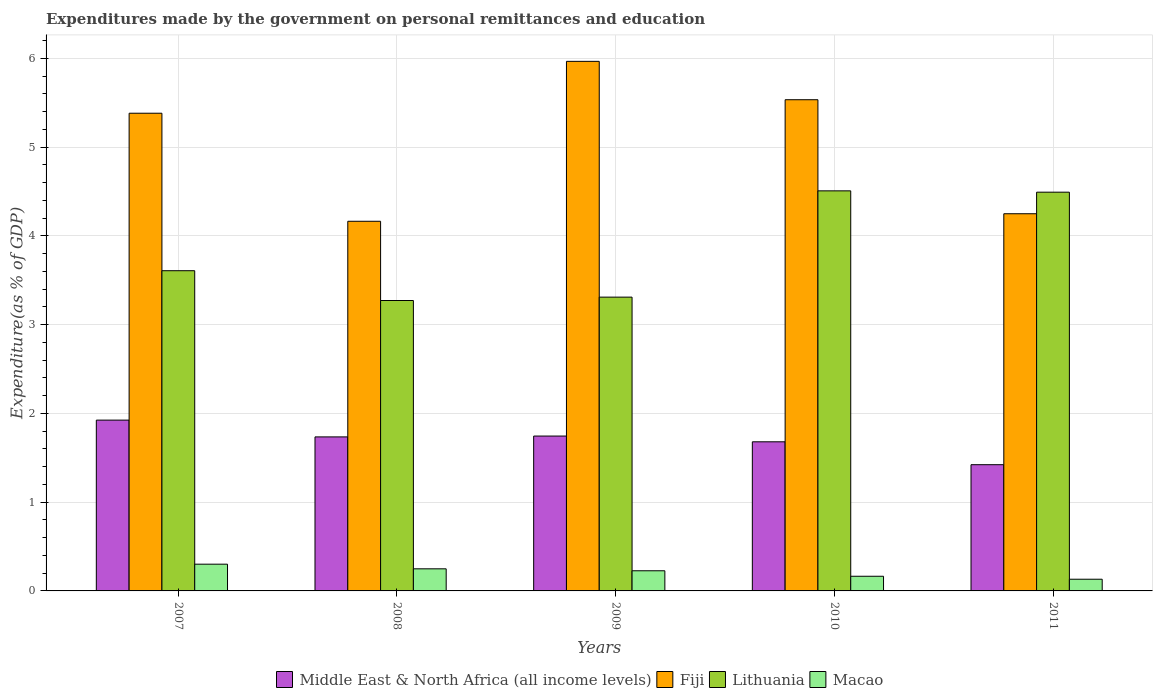How many different coloured bars are there?
Keep it short and to the point. 4. Are the number of bars per tick equal to the number of legend labels?
Provide a succinct answer. Yes. How many bars are there on the 5th tick from the left?
Make the answer very short. 4. In how many cases, is the number of bars for a given year not equal to the number of legend labels?
Offer a very short reply. 0. What is the expenditures made by the government on personal remittances and education in Fiji in 2008?
Your answer should be very brief. 4.16. Across all years, what is the maximum expenditures made by the government on personal remittances and education in Macao?
Your answer should be very brief. 0.3. Across all years, what is the minimum expenditures made by the government on personal remittances and education in Fiji?
Make the answer very short. 4.16. In which year was the expenditures made by the government on personal remittances and education in Middle East & North Africa (all income levels) minimum?
Your response must be concise. 2011. What is the total expenditures made by the government on personal remittances and education in Lithuania in the graph?
Provide a succinct answer. 19.19. What is the difference between the expenditures made by the government on personal remittances and education in Lithuania in 2008 and that in 2011?
Offer a very short reply. -1.22. What is the difference between the expenditures made by the government on personal remittances and education in Lithuania in 2008 and the expenditures made by the government on personal remittances and education in Macao in 2010?
Keep it short and to the point. 3.11. What is the average expenditures made by the government on personal remittances and education in Macao per year?
Ensure brevity in your answer.  0.21. In the year 2011, what is the difference between the expenditures made by the government on personal remittances and education in Fiji and expenditures made by the government on personal remittances and education in Middle East & North Africa (all income levels)?
Offer a terse response. 2.83. In how many years, is the expenditures made by the government on personal remittances and education in Macao greater than 4.6 %?
Offer a very short reply. 0. What is the ratio of the expenditures made by the government on personal remittances and education in Lithuania in 2007 to that in 2009?
Keep it short and to the point. 1.09. What is the difference between the highest and the second highest expenditures made by the government on personal remittances and education in Lithuania?
Offer a very short reply. 0.01. What is the difference between the highest and the lowest expenditures made by the government on personal remittances and education in Macao?
Your answer should be compact. 0.17. In how many years, is the expenditures made by the government on personal remittances and education in Fiji greater than the average expenditures made by the government on personal remittances and education in Fiji taken over all years?
Your response must be concise. 3. Is the sum of the expenditures made by the government on personal remittances and education in Lithuania in 2009 and 2010 greater than the maximum expenditures made by the government on personal remittances and education in Macao across all years?
Provide a short and direct response. Yes. Is it the case that in every year, the sum of the expenditures made by the government on personal remittances and education in Middle East & North Africa (all income levels) and expenditures made by the government on personal remittances and education in Macao is greater than the sum of expenditures made by the government on personal remittances and education in Lithuania and expenditures made by the government on personal remittances and education in Fiji?
Your answer should be very brief. No. What does the 2nd bar from the left in 2009 represents?
Provide a succinct answer. Fiji. What does the 3rd bar from the right in 2011 represents?
Keep it short and to the point. Fiji. Are all the bars in the graph horizontal?
Keep it short and to the point. No. How many years are there in the graph?
Offer a terse response. 5. Are the values on the major ticks of Y-axis written in scientific E-notation?
Keep it short and to the point. No. Does the graph contain any zero values?
Ensure brevity in your answer.  No. How many legend labels are there?
Give a very brief answer. 4. How are the legend labels stacked?
Offer a very short reply. Horizontal. What is the title of the graph?
Your response must be concise. Expenditures made by the government on personal remittances and education. What is the label or title of the X-axis?
Your response must be concise. Years. What is the label or title of the Y-axis?
Give a very brief answer. Expenditure(as % of GDP). What is the Expenditure(as % of GDP) of Middle East & North Africa (all income levels) in 2007?
Offer a terse response. 1.92. What is the Expenditure(as % of GDP) in Fiji in 2007?
Give a very brief answer. 5.38. What is the Expenditure(as % of GDP) of Lithuania in 2007?
Provide a short and direct response. 3.61. What is the Expenditure(as % of GDP) in Macao in 2007?
Give a very brief answer. 0.3. What is the Expenditure(as % of GDP) in Middle East & North Africa (all income levels) in 2008?
Provide a succinct answer. 1.73. What is the Expenditure(as % of GDP) in Fiji in 2008?
Offer a terse response. 4.16. What is the Expenditure(as % of GDP) of Lithuania in 2008?
Keep it short and to the point. 3.27. What is the Expenditure(as % of GDP) in Macao in 2008?
Your answer should be compact. 0.25. What is the Expenditure(as % of GDP) of Middle East & North Africa (all income levels) in 2009?
Provide a short and direct response. 1.74. What is the Expenditure(as % of GDP) in Fiji in 2009?
Ensure brevity in your answer.  5.97. What is the Expenditure(as % of GDP) of Lithuania in 2009?
Ensure brevity in your answer.  3.31. What is the Expenditure(as % of GDP) in Macao in 2009?
Provide a short and direct response. 0.23. What is the Expenditure(as % of GDP) of Middle East & North Africa (all income levels) in 2010?
Your answer should be very brief. 1.68. What is the Expenditure(as % of GDP) of Fiji in 2010?
Provide a short and direct response. 5.53. What is the Expenditure(as % of GDP) in Lithuania in 2010?
Give a very brief answer. 4.51. What is the Expenditure(as % of GDP) in Macao in 2010?
Give a very brief answer. 0.17. What is the Expenditure(as % of GDP) of Middle East & North Africa (all income levels) in 2011?
Provide a short and direct response. 1.42. What is the Expenditure(as % of GDP) of Fiji in 2011?
Ensure brevity in your answer.  4.25. What is the Expenditure(as % of GDP) of Lithuania in 2011?
Provide a short and direct response. 4.49. What is the Expenditure(as % of GDP) in Macao in 2011?
Provide a succinct answer. 0.13. Across all years, what is the maximum Expenditure(as % of GDP) of Middle East & North Africa (all income levels)?
Provide a short and direct response. 1.92. Across all years, what is the maximum Expenditure(as % of GDP) of Fiji?
Keep it short and to the point. 5.97. Across all years, what is the maximum Expenditure(as % of GDP) in Lithuania?
Keep it short and to the point. 4.51. Across all years, what is the maximum Expenditure(as % of GDP) of Macao?
Offer a terse response. 0.3. Across all years, what is the minimum Expenditure(as % of GDP) of Middle East & North Africa (all income levels)?
Keep it short and to the point. 1.42. Across all years, what is the minimum Expenditure(as % of GDP) in Fiji?
Give a very brief answer. 4.16. Across all years, what is the minimum Expenditure(as % of GDP) in Lithuania?
Your answer should be very brief. 3.27. Across all years, what is the minimum Expenditure(as % of GDP) of Macao?
Your answer should be very brief. 0.13. What is the total Expenditure(as % of GDP) in Middle East & North Africa (all income levels) in the graph?
Ensure brevity in your answer.  8.51. What is the total Expenditure(as % of GDP) of Fiji in the graph?
Provide a succinct answer. 25.29. What is the total Expenditure(as % of GDP) in Lithuania in the graph?
Make the answer very short. 19.19. What is the total Expenditure(as % of GDP) in Macao in the graph?
Your answer should be very brief. 1.07. What is the difference between the Expenditure(as % of GDP) of Middle East & North Africa (all income levels) in 2007 and that in 2008?
Keep it short and to the point. 0.19. What is the difference between the Expenditure(as % of GDP) of Fiji in 2007 and that in 2008?
Provide a short and direct response. 1.22. What is the difference between the Expenditure(as % of GDP) in Lithuania in 2007 and that in 2008?
Your answer should be very brief. 0.34. What is the difference between the Expenditure(as % of GDP) of Macao in 2007 and that in 2008?
Offer a very short reply. 0.05. What is the difference between the Expenditure(as % of GDP) of Middle East & North Africa (all income levels) in 2007 and that in 2009?
Your answer should be very brief. 0.18. What is the difference between the Expenditure(as % of GDP) in Fiji in 2007 and that in 2009?
Offer a terse response. -0.58. What is the difference between the Expenditure(as % of GDP) of Lithuania in 2007 and that in 2009?
Keep it short and to the point. 0.3. What is the difference between the Expenditure(as % of GDP) in Macao in 2007 and that in 2009?
Your response must be concise. 0.07. What is the difference between the Expenditure(as % of GDP) of Middle East & North Africa (all income levels) in 2007 and that in 2010?
Give a very brief answer. 0.24. What is the difference between the Expenditure(as % of GDP) of Fiji in 2007 and that in 2010?
Keep it short and to the point. -0.15. What is the difference between the Expenditure(as % of GDP) in Lithuania in 2007 and that in 2010?
Keep it short and to the point. -0.9. What is the difference between the Expenditure(as % of GDP) of Macao in 2007 and that in 2010?
Offer a very short reply. 0.14. What is the difference between the Expenditure(as % of GDP) of Middle East & North Africa (all income levels) in 2007 and that in 2011?
Provide a succinct answer. 0.5. What is the difference between the Expenditure(as % of GDP) in Fiji in 2007 and that in 2011?
Your response must be concise. 1.13. What is the difference between the Expenditure(as % of GDP) in Lithuania in 2007 and that in 2011?
Your answer should be compact. -0.88. What is the difference between the Expenditure(as % of GDP) of Macao in 2007 and that in 2011?
Your answer should be compact. 0.17. What is the difference between the Expenditure(as % of GDP) of Middle East & North Africa (all income levels) in 2008 and that in 2009?
Ensure brevity in your answer.  -0.01. What is the difference between the Expenditure(as % of GDP) of Fiji in 2008 and that in 2009?
Provide a short and direct response. -1.8. What is the difference between the Expenditure(as % of GDP) in Lithuania in 2008 and that in 2009?
Keep it short and to the point. -0.04. What is the difference between the Expenditure(as % of GDP) in Macao in 2008 and that in 2009?
Give a very brief answer. 0.02. What is the difference between the Expenditure(as % of GDP) in Middle East & North Africa (all income levels) in 2008 and that in 2010?
Your answer should be very brief. 0.06. What is the difference between the Expenditure(as % of GDP) of Fiji in 2008 and that in 2010?
Ensure brevity in your answer.  -1.37. What is the difference between the Expenditure(as % of GDP) of Lithuania in 2008 and that in 2010?
Ensure brevity in your answer.  -1.24. What is the difference between the Expenditure(as % of GDP) of Macao in 2008 and that in 2010?
Provide a short and direct response. 0.08. What is the difference between the Expenditure(as % of GDP) of Middle East & North Africa (all income levels) in 2008 and that in 2011?
Provide a succinct answer. 0.31. What is the difference between the Expenditure(as % of GDP) of Fiji in 2008 and that in 2011?
Keep it short and to the point. -0.08. What is the difference between the Expenditure(as % of GDP) in Lithuania in 2008 and that in 2011?
Offer a very short reply. -1.22. What is the difference between the Expenditure(as % of GDP) in Macao in 2008 and that in 2011?
Keep it short and to the point. 0.12. What is the difference between the Expenditure(as % of GDP) of Middle East & North Africa (all income levels) in 2009 and that in 2010?
Offer a very short reply. 0.06. What is the difference between the Expenditure(as % of GDP) of Fiji in 2009 and that in 2010?
Your response must be concise. 0.43. What is the difference between the Expenditure(as % of GDP) of Lithuania in 2009 and that in 2010?
Make the answer very short. -1.2. What is the difference between the Expenditure(as % of GDP) of Macao in 2009 and that in 2010?
Provide a succinct answer. 0.06. What is the difference between the Expenditure(as % of GDP) of Middle East & North Africa (all income levels) in 2009 and that in 2011?
Keep it short and to the point. 0.32. What is the difference between the Expenditure(as % of GDP) in Fiji in 2009 and that in 2011?
Offer a very short reply. 1.72. What is the difference between the Expenditure(as % of GDP) of Lithuania in 2009 and that in 2011?
Ensure brevity in your answer.  -1.18. What is the difference between the Expenditure(as % of GDP) in Macao in 2009 and that in 2011?
Your answer should be very brief. 0.1. What is the difference between the Expenditure(as % of GDP) in Middle East & North Africa (all income levels) in 2010 and that in 2011?
Offer a terse response. 0.26. What is the difference between the Expenditure(as % of GDP) of Fiji in 2010 and that in 2011?
Offer a very short reply. 1.28. What is the difference between the Expenditure(as % of GDP) of Lithuania in 2010 and that in 2011?
Provide a succinct answer. 0.01. What is the difference between the Expenditure(as % of GDP) in Macao in 2010 and that in 2011?
Your answer should be compact. 0.03. What is the difference between the Expenditure(as % of GDP) in Middle East & North Africa (all income levels) in 2007 and the Expenditure(as % of GDP) in Fiji in 2008?
Ensure brevity in your answer.  -2.24. What is the difference between the Expenditure(as % of GDP) in Middle East & North Africa (all income levels) in 2007 and the Expenditure(as % of GDP) in Lithuania in 2008?
Offer a terse response. -1.35. What is the difference between the Expenditure(as % of GDP) in Middle East & North Africa (all income levels) in 2007 and the Expenditure(as % of GDP) in Macao in 2008?
Ensure brevity in your answer.  1.68. What is the difference between the Expenditure(as % of GDP) of Fiji in 2007 and the Expenditure(as % of GDP) of Lithuania in 2008?
Offer a terse response. 2.11. What is the difference between the Expenditure(as % of GDP) of Fiji in 2007 and the Expenditure(as % of GDP) of Macao in 2008?
Offer a very short reply. 5.13. What is the difference between the Expenditure(as % of GDP) of Lithuania in 2007 and the Expenditure(as % of GDP) of Macao in 2008?
Your answer should be compact. 3.36. What is the difference between the Expenditure(as % of GDP) in Middle East & North Africa (all income levels) in 2007 and the Expenditure(as % of GDP) in Fiji in 2009?
Give a very brief answer. -4.04. What is the difference between the Expenditure(as % of GDP) in Middle East & North Africa (all income levels) in 2007 and the Expenditure(as % of GDP) in Lithuania in 2009?
Give a very brief answer. -1.39. What is the difference between the Expenditure(as % of GDP) in Middle East & North Africa (all income levels) in 2007 and the Expenditure(as % of GDP) in Macao in 2009?
Offer a very short reply. 1.7. What is the difference between the Expenditure(as % of GDP) in Fiji in 2007 and the Expenditure(as % of GDP) in Lithuania in 2009?
Your response must be concise. 2.07. What is the difference between the Expenditure(as % of GDP) in Fiji in 2007 and the Expenditure(as % of GDP) in Macao in 2009?
Keep it short and to the point. 5.15. What is the difference between the Expenditure(as % of GDP) of Lithuania in 2007 and the Expenditure(as % of GDP) of Macao in 2009?
Your answer should be compact. 3.38. What is the difference between the Expenditure(as % of GDP) in Middle East & North Africa (all income levels) in 2007 and the Expenditure(as % of GDP) in Fiji in 2010?
Your response must be concise. -3.61. What is the difference between the Expenditure(as % of GDP) in Middle East & North Africa (all income levels) in 2007 and the Expenditure(as % of GDP) in Lithuania in 2010?
Keep it short and to the point. -2.58. What is the difference between the Expenditure(as % of GDP) of Middle East & North Africa (all income levels) in 2007 and the Expenditure(as % of GDP) of Macao in 2010?
Your answer should be compact. 1.76. What is the difference between the Expenditure(as % of GDP) of Fiji in 2007 and the Expenditure(as % of GDP) of Lithuania in 2010?
Make the answer very short. 0.87. What is the difference between the Expenditure(as % of GDP) in Fiji in 2007 and the Expenditure(as % of GDP) in Macao in 2010?
Keep it short and to the point. 5.22. What is the difference between the Expenditure(as % of GDP) of Lithuania in 2007 and the Expenditure(as % of GDP) of Macao in 2010?
Your response must be concise. 3.44. What is the difference between the Expenditure(as % of GDP) in Middle East & North Africa (all income levels) in 2007 and the Expenditure(as % of GDP) in Fiji in 2011?
Your answer should be compact. -2.32. What is the difference between the Expenditure(as % of GDP) of Middle East & North Africa (all income levels) in 2007 and the Expenditure(as % of GDP) of Lithuania in 2011?
Make the answer very short. -2.57. What is the difference between the Expenditure(as % of GDP) in Middle East & North Africa (all income levels) in 2007 and the Expenditure(as % of GDP) in Macao in 2011?
Ensure brevity in your answer.  1.79. What is the difference between the Expenditure(as % of GDP) of Fiji in 2007 and the Expenditure(as % of GDP) of Lithuania in 2011?
Make the answer very short. 0.89. What is the difference between the Expenditure(as % of GDP) of Fiji in 2007 and the Expenditure(as % of GDP) of Macao in 2011?
Your response must be concise. 5.25. What is the difference between the Expenditure(as % of GDP) in Lithuania in 2007 and the Expenditure(as % of GDP) in Macao in 2011?
Give a very brief answer. 3.48. What is the difference between the Expenditure(as % of GDP) of Middle East & North Africa (all income levels) in 2008 and the Expenditure(as % of GDP) of Fiji in 2009?
Provide a short and direct response. -4.23. What is the difference between the Expenditure(as % of GDP) in Middle East & North Africa (all income levels) in 2008 and the Expenditure(as % of GDP) in Lithuania in 2009?
Ensure brevity in your answer.  -1.57. What is the difference between the Expenditure(as % of GDP) of Middle East & North Africa (all income levels) in 2008 and the Expenditure(as % of GDP) of Macao in 2009?
Make the answer very short. 1.51. What is the difference between the Expenditure(as % of GDP) of Fiji in 2008 and the Expenditure(as % of GDP) of Lithuania in 2009?
Give a very brief answer. 0.85. What is the difference between the Expenditure(as % of GDP) in Fiji in 2008 and the Expenditure(as % of GDP) in Macao in 2009?
Keep it short and to the point. 3.94. What is the difference between the Expenditure(as % of GDP) of Lithuania in 2008 and the Expenditure(as % of GDP) of Macao in 2009?
Your response must be concise. 3.04. What is the difference between the Expenditure(as % of GDP) in Middle East & North Africa (all income levels) in 2008 and the Expenditure(as % of GDP) in Fiji in 2010?
Keep it short and to the point. -3.8. What is the difference between the Expenditure(as % of GDP) of Middle East & North Africa (all income levels) in 2008 and the Expenditure(as % of GDP) of Lithuania in 2010?
Your answer should be compact. -2.77. What is the difference between the Expenditure(as % of GDP) of Middle East & North Africa (all income levels) in 2008 and the Expenditure(as % of GDP) of Macao in 2010?
Offer a terse response. 1.57. What is the difference between the Expenditure(as % of GDP) of Fiji in 2008 and the Expenditure(as % of GDP) of Lithuania in 2010?
Keep it short and to the point. -0.34. What is the difference between the Expenditure(as % of GDP) in Fiji in 2008 and the Expenditure(as % of GDP) in Macao in 2010?
Keep it short and to the point. 4. What is the difference between the Expenditure(as % of GDP) in Lithuania in 2008 and the Expenditure(as % of GDP) in Macao in 2010?
Keep it short and to the point. 3.11. What is the difference between the Expenditure(as % of GDP) in Middle East & North Africa (all income levels) in 2008 and the Expenditure(as % of GDP) in Fiji in 2011?
Your answer should be compact. -2.51. What is the difference between the Expenditure(as % of GDP) of Middle East & North Africa (all income levels) in 2008 and the Expenditure(as % of GDP) of Lithuania in 2011?
Keep it short and to the point. -2.76. What is the difference between the Expenditure(as % of GDP) of Middle East & North Africa (all income levels) in 2008 and the Expenditure(as % of GDP) of Macao in 2011?
Give a very brief answer. 1.6. What is the difference between the Expenditure(as % of GDP) in Fiji in 2008 and the Expenditure(as % of GDP) in Lithuania in 2011?
Keep it short and to the point. -0.33. What is the difference between the Expenditure(as % of GDP) in Fiji in 2008 and the Expenditure(as % of GDP) in Macao in 2011?
Offer a terse response. 4.03. What is the difference between the Expenditure(as % of GDP) of Lithuania in 2008 and the Expenditure(as % of GDP) of Macao in 2011?
Provide a short and direct response. 3.14. What is the difference between the Expenditure(as % of GDP) in Middle East & North Africa (all income levels) in 2009 and the Expenditure(as % of GDP) in Fiji in 2010?
Offer a terse response. -3.79. What is the difference between the Expenditure(as % of GDP) of Middle East & North Africa (all income levels) in 2009 and the Expenditure(as % of GDP) of Lithuania in 2010?
Ensure brevity in your answer.  -2.76. What is the difference between the Expenditure(as % of GDP) in Middle East & North Africa (all income levels) in 2009 and the Expenditure(as % of GDP) in Macao in 2010?
Offer a very short reply. 1.58. What is the difference between the Expenditure(as % of GDP) of Fiji in 2009 and the Expenditure(as % of GDP) of Lithuania in 2010?
Your answer should be very brief. 1.46. What is the difference between the Expenditure(as % of GDP) of Fiji in 2009 and the Expenditure(as % of GDP) of Macao in 2010?
Give a very brief answer. 5.8. What is the difference between the Expenditure(as % of GDP) in Lithuania in 2009 and the Expenditure(as % of GDP) in Macao in 2010?
Offer a terse response. 3.14. What is the difference between the Expenditure(as % of GDP) in Middle East & North Africa (all income levels) in 2009 and the Expenditure(as % of GDP) in Fiji in 2011?
Ensure brevity in your answer.  -2.5. What is the difference between the Expenditure(as % of GDP) in Middle East & North Africa (all income levels) in 2009 and the Expenditure(as % of GDP) in Lithuania in 2011?
Your answer should be very brief. -2.75. What is the difference between the Expenditure(as % of GDP) in Middle East & North Africa (all income levels) in 2009 and the Expenditure(as % of GDP) in Macao in 2011?
Make the answer very short. 1.61. What is the difference between the Expenditure(as % of GDP) in Fiji in 2009 and the Expenditure(as % of GDP) in Lithuania in 2011?
Keep it short and to the point. 1.47. What is the difference between the Expenditure(as % of GDP) of Fiji in 2009 and the Expenditure(as % of GDP) of Macao in 2011?
Give a very brief answer. 5.83. What is the difference between the Expenditure(as % of GDP) of Lithuania in 2009 and the Expenditure(as % of GDP) of Macao in 2011?
Your response must be concise. 3.18. What is the difference between the Expenditure(as % of GDP) of Middle East & North Africa (all income levels) in 2010 and the Expenditure(as % of GDP) of Fiji in 2011?
Offer a terse response. -2.57. What is the difference between the Expenditure(as % of GDP) of Middle East & North Africa (all income levels) in 2010 and the Expenditure(as % of GDP) of Lithuania in 2011?
Provide a short and direct response. -2.81. What is the difference between the Expenditure(as % of GDP) of Middle East & North Africa (all income levels) in 2010 and the Expenditure(as % of GDP) of Macao in 2011?
Provide a short and direct response. 1.55. What is the difference between the Expenditure(as % of GDP) of Fiji in 2010 and the Expenditure(as % of GDP) of Lithuania in 2011?
Provide a short and direct response. 1.04. What is the difference between the Expenditure(as % of GDP) in Fiji in 2010 and the Expenditure(as % of GDP) in Macao in 2011?
Offer a very short reply. 5.4. What is the difference between the Expenditure(as % of GDP) of Lithuania in 2010 and the Expenditure(as % of GDP) of Macao in 2011?
Provide a succinct answer. 4.37. What is the average Expenditure(as % of GDP) of Middle East & North Africa (all income levels) per year?
Your response must be concise. 1.7. What is the average Expenditure(as % of GDP) of Fiji per year?
Keep it short and to the point. 5.06. What is the average Expenditure(as % of GDP) of Lithuania per year?
Your answer should be compact. 3.84. What is the average Expenditure(as % of GDP) in Macao per year?
Give a very brief answer. 0.21. In the year 2007, what is the difference between the Expenditure(as % of GDP) in Middle East & North Africa (all income levels) and Expenditure(as % of GDP) in Fiji?
Offer a very short reply. -3.46. In the year 2007, what is the difference between the Expenditure(as % of GDP) in Middle East & North Africa (all income levels) and Expenditure(as % of GDP) in Lithuania?
Provide a short and direct response. -1.68. In the year 2007, what is the difference between the Expenditure(as % of GDP) in Middle East & North Africa (all income levels) and Expenditure(as % of GDP) in Macao?
Provide a short and direct response. 1.62. In the year 2007, what is the difference between the Expenditure(as % of GDP) in Fiji and Expenditure(as % of GDP) in Lithuania?
Keep it short and to the point. 1.77. In the year 2007, what is the difference between the Expenditure(as % of GDP) of Fiji and Expenditure(as % of GDP) of Macao?
Your answer should be very brief. 5.08. In the year 2007, what is the difference between the Expenditure(as % of GDP) of Lithuania and Expenditure(as % of GDP) of Macao?
Offer a very short reply. 3.31. In the year 2008, what is the difference between the Expenditure(as % of GDP) of Middle East & North Africa (all income levels) and Expenditure(as % of GDP) of Fiji?
Provide a succinct answer. -2.43. In the year 2008, what is the difference between the Expenditure(as % of GDP) in Middle East & North Africa (all income levels) and Expenditure(as % of GDP) in Lithuania?
Your answer should be very brief. -1.54. In the year 2008, what is the difference between the Expenditure(as % of GDP) in Middle East & North Africa (all income levels) and Expenditure(as % of GDP) in Macao?
Your response must be concise. 1.49. In the year 2008, what is the difference between the Expenditure(as % of GDP) of Fiji and Expenditure(as % of GDP) of Lithuania?
Offer a terse response. 0.89. In the year 2008, what is the difference between the Expenditure(as % of GDP) of Fiji and Expenditure(as % of GDP) of Macao?
Provide a short and direct response. 3.92. In the year 2008, what is the difference between the Expenditure(as % of GDP) of Lithuania and Expenditure(as % of GDP) of Macao?
Offer a terse response. 3.02. In the year 2009, what is the difference between the Expenditure(as % of GDP) in Middle East & North Africa (all income levels) and Expenditure(as % of GDP) in Fiji?
Provide a succinct answer. -4.22. In the year 2009, what is the difference between the Expenditure(as % of GDP) of Middle East & North Africa (all income levels) and Expenditure(as % of GDP) of Lithuania?
Your answer should be compact. -1.56. In the year 2009, what is the difference between the Expenditure(as % of GDP) in Middle East & North Africa (all income levels) and Expenditure(as % of GDP) in Macao?
Your answer should be very brief. 1.52. In the year 2009, what is the difference between the Expenditure(as % of GDP) of Fiji and Expenditure(as % of GDP) of Lithuania?
Offer a very short reply. 2.66. In the year 2009, what is the difference between the Expenditure(as % of GDP) in Fiji and Expenditure(as % of GDP) in Macao?
Provide a short and direct response. 5.74. In the year 2009, what is the difference between the Expenditure(as % of GDP) in Lithuania and Expenditure(as % of GDP) in Macao?
Make the answer very short. 3.08. In the year 2010, what is the difference between the Expenditure(as % of GDP) of Middle East & North Africa (all income levels) and Expenditure(as % of GDP) of Fiji?
Give a very brief answer. -3.85. In the year 2010, what is the difference between the Expenditure(as % of GDP) of Middle East & North Africa (all income levels) and Expenditure(as % of GDP) of Lithuania?
Ensure brevity in your answer.  -2.83. In the year 2010, what is the difference between the Expenditure(as % of GDP) in Middle East & North Africa (all income levels) and Expenditure(as % of GDP) in Macao?
Provide a succinct answer. 1.51. In the year 2010, what is the difference between the Expenditure(as % of GDP) of Fiji and Expenditure(as % of GDP) of Lithuania?
Keep it short and to the point. 1.03. In the year 2010, what is the difference between the Expenditure(as % of GDP) of Fiji and Expenditure(as % of GDP) of Macao?
Keep it short and to the point. 5.37. In the year 2010, what is the difference between the Expenditure(as % of GDP) in Lithuania and Expenditure(as % of GDP) in Macao?
Make the answer very short. 4.34. In the year 2011, what is the difference between the Expenditure(as % of GDP) in Middle East & North Africa (all income levels) and Expenditure(as % of GDP) in Fiji?
Your response must be concise. -2.83. In the year 2011, what is the difference between the Expenditure(as % of GDP) of Middle East & North Africa (all income levels) and Expenditure(as % of GDP) of Lithuania?
Your answer should be very brief. -3.07. In the year 2011, what is the difference between the Expenditure(as % of GDP) in Middle East & North Africa (all income levels) and Expenditure(as % of GDP) in Macao?
Offer a terse response. 1.29. In the year 2011, what is the difference between the Expenditure(as % of GDP) of Fiji and Expenditure(as % of GDP) of Lithuania?
Your response must be concise. -0.24. In the year 2011, what is the difference between the Expenditure(as % of GDP) in Fiji and Expenditure(as % of GDP) in Macao?
Your response must be concise. 4.12. In the year 2011, what is the difference between the Expenditure(as % of GDP) in Lithuania and Expenditure(as % of GDP) in Macao?
Your response must be concise. 4.36. What is the ratio of the Expenditure(as % of GDP) in Middle East & North Africa (all income levels) in 2007 to that in 2008?
Provide a short and direct response. 1.11. What is the ratio of the Expenditure(as % of GDP) of Fiji in 2007 to that in 2008?
Offer a very short reply. 1.29. What is the ratio of the Expenditure(as % of GDP) of Lithuania in 2007 to that in 2008?
Provide a short and direct response. 1.1. What is the ratio of the Expenditure(as % of GDP) of Macao in 2007 to that in 2008?
Provide a short and direct response. 1.21. What is the ratio of the Expenditure(as % of GDP) of Middle East & North Africa (all income levels) in 2007 to that in 2009?
Offer a very short reply. 1.1. What is the ratio of the Expenditure(as % of GDP) of Fiji in 2007 to that in 2009?
Provide a short and direct response. 0.9. What is the ratio of the Expenditure(as % of GDP) in Lithuania in 2007 to that in 2009?
Give a very brief answer. 1.09. What is the ratio of the Expenditure(as % of GDP) of Macao in 2007 to that in 2009?
Provide a short and direct response. 1.33. What is the ratio of the Expenditure(as % of GDP) of Middle East & North Africa (all income levels) in 2007 to that in 2010?
Offer a very short reply. 1.15. What is the ratio of the Expenditure(as % of GDP) of Fiji in 2007 to that in 2010?
Your answer should be compact. 0.97. What is the ratio of the Expenditure(as % of GDP) of Lithuania in 2007 to that in 2010?
Keep it short and to the point. 0.8. What is the ratio of the Expenditure(as % of GDP) in Macao in 2007 to that in 2010?
Give a very brief answer. 1.82. What is the ratio of the Expenditure(as % of GDP) in Middle East & North Africa (all income levels) in 2007 to that in 2011?
Your answer should be very brief. 1.35. What is the ratio of the Expenditure(as % of GDP) in Fiji in 2007 to that in 2011?
Provide a succinct answer. 1.27. What is the ratio of the Expenditure(as % of GDP) of Lithuania in 2007 to that in 2011?
Your response must be concise. 0.8. What is the ratio of the Expenditure(as % of GDP) of Macao in 2007 to that in 2011?
Your answer should be very brief. 2.29. What is the ratio of the Expenditure(as % of GDP) of Middle East & North Africa (all income levels) in 2008 to that in 2009?
Your answer should be very brief. 0.99. What is the ratio of the Expenditure(as % of GDP) of Fiji in 2008 to that in 2009?
Make the answer very short. 0.7. What is the ratio of the Expenditure(as % of GDP) of Lithuania in 2008 to that in 2009?
Make the answer very short. 0.99. What is the ratio of the Expenditure(as % of GDP) of Macao in 2008 to that in 2009?
Provide a short and direct response. 1.1. What is the ratio of the Expenditure(as % of GDP) of Middle East & North Africa (all income levels) in 2008 to that in 2010?
Offer a very short reply. 1.03. What is the ratio of the Expenditure(as % of GDP) of Fiji in 2008 to that in 2010?
Offer a terse response. 0.75. What is the ratio of the Expenditure(as % of GDP) in Lithuania in 2008 to that in 2010?
Offer a terse response. 0.73. What is the ratio of the Expenditure(as % of GDP) in Macao in 2008 to that in 2010?
Your answer should be compact. 1.51. What is the ratio of the Expenditure(as % of GDP) in Middle East & North Africa (all income levels) in 2008 to that in 2011?
Offer a terse response. 1.22. What is the ratio of the Expenditure(as % of GDP) in Fiji in 2008 to that in 2011?
Keep it short and to the point. 0.98. What is the ratio of the Expenditure(as % of GDP) of Lithuania in 2008 to that in 2011?
Your response must be concise. 0.73. What is the ratio of the Expenditure(as % of GDP) of Macao in 2008 to that in 2011?
Your answer should be very brief. 1.89. What is the ratio of the Expenditure(as % of GDP) in Middle East & North Africa (all income levels) in 2009 to that in 2010?
Offer a terse response. 1.04. What is the ratio of the Expenditure(as % of GDP) of Fiji in 2009 to that in 2010?
Offer a very short reply. 1.08. What is the ratio of the Expenditure(as % of GDP) of Lithuania in 2009 to that in 2010?
Offer a very short reply. 0.73. What is the ratio of the Expenditure(as % of GDP) in Macao in 2009 to that in 2010?
Your answer should be compact. 1.37. What is the ratio of the Expenditure(as % of GDP) of Middle East & North Africa (all income levels) in 2009 to that in 2011?
Ensure brevity in your answer.  1.23. What is the ratio of the Expenditure(as % of GDP) of Fiji in 2009 to that in 2011?
Provide a succinct answer. 1.4. What is the ratio of the Expenditure(as % of GDP) in Lithuania in 2009 to that in 2011?
Offer a very short reply. 0.74. What is the ratio of the Expenditure(as % of GDP) in Macao in 2009 to that in 2011?
Keep it short and to the point. 1.72. What is the ratio of the Expenditure(as % of GDP) in Middle East & North Africa (all income levels) in 2010 to that in 2011?
Ensure brevity in your answer.  1.18. What is the ratio of the Expenditure(as % of GDP) in Fiji in 2010 to that in 2011?
Give a very brief answer. 1.3. What is the ratio of the Expenditure(as % of GDP) in Macao in 2010 to that in 2011?
Your response must be concise. 1.25. What is the difference between the highest and the second highest Expenditure(as % of GDP) in Middle East & North Africa (all income levels)?
Your answer should be compact. 0.18. What is the difference between the highest and the second highest Expenditure(as % of GDP) in Fiji?
Ensure brevity in your answer.  0.43. What is the difference between the highest and the second highest Expenditure(as % of GDP) in Lithuania?
Your answer should be very brief. 0.01. What is the difference between the highest and the second highest Expenditure(as % of GDP) in Macao?
Provide a succinct answer. 0.05. What is the difference between the highest and the lowest Expenditure(as % of GDP) in Middle East & North Africa (all income levels)?
Keep it short and to the point. 0.5. What is the difference between the highest and the lowest Expenditure(as % of GDP) of Fiji?
Provide a succinct answer. 1.8. What is the difference between the highest and the lowest Expenditure(as % of GDP) in Lithuania?
Your response must be concise. 1.24. What is the difference between the highest and the lowest Expenditure(as % of GDP) of Macao?
Offer a very short reply. 0.17. 